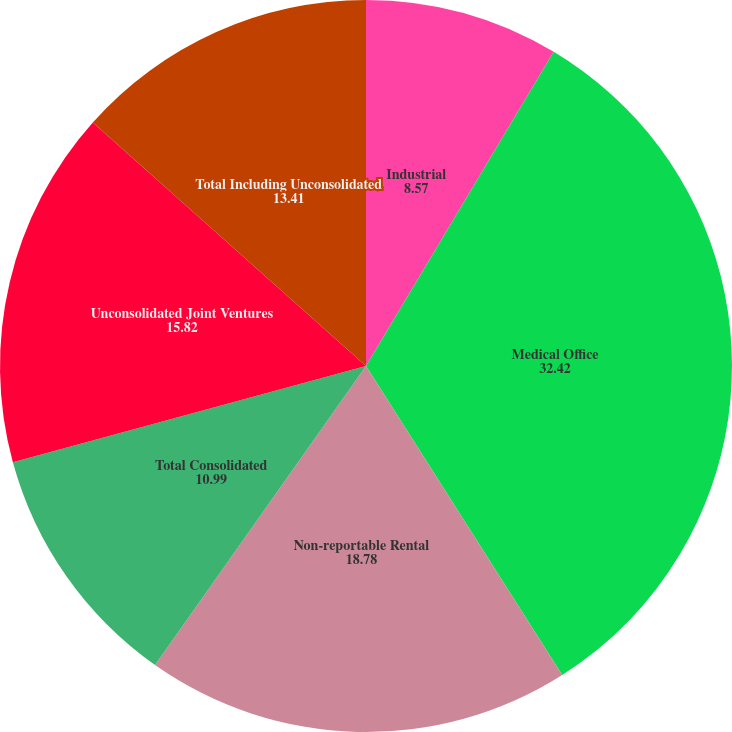Convert chart to OTSL. <chart><loc_0><loc_0><loc_500><loc_500><pie_chart><fcel>Industrial<fcel>Medical Office<fcel>Non-reportable Rental<fcel>Total Consolidated<fcel>Unconsolidated Joint Ventures<fcel>Total Including Unconsolidated<nl><fcel>8.57%<fcel>32.42%<fcel>18.78%<fcel>10.99%<fcel>15.82%<fcel>13.41%<nl></chart> 